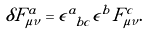<formula> <loc_0><loc_0><loc_500><loc_500>\delta F ^ { a } _ { \mu \nu } = \epsilon ^ { a } _ { \ b c } \epsilon ^ { b } F ^ { c } _ { \mu \nu } .</formula> 